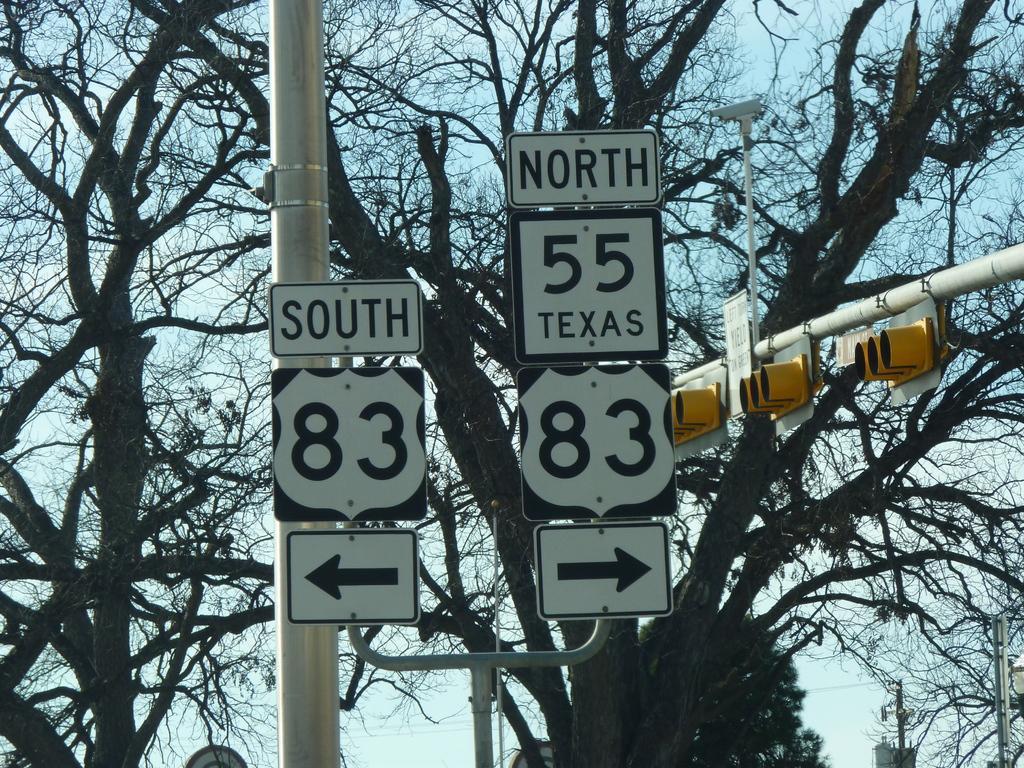Could you give a brief overview of what you see in this image? In this image there are sign boards and signal lights, in the background there are trees and the sky. 